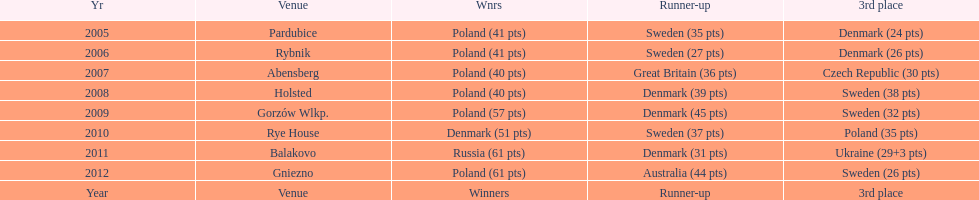What was the last year 3rd place finished with less than 25 points? 2005. 